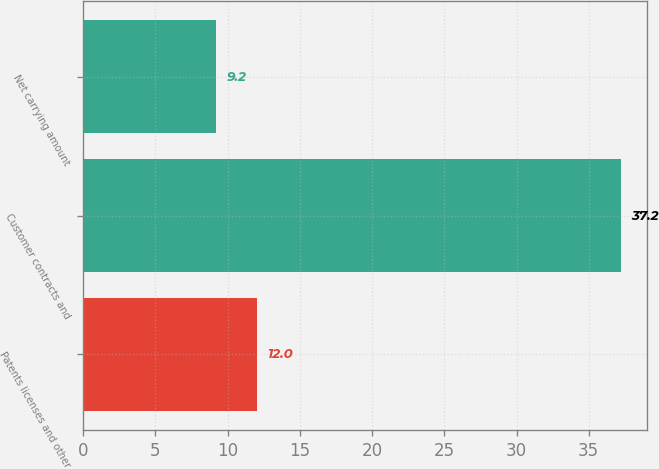Convert chart. <chart><loc_0><loc_0><loc_500><loc_500><bar_chart><fcel>Patents licenses and other<fcel>Customer contracts and<fcel>Net carrying amount<nl><fcel>12<fcel>37.2<fcel>9.2<nl></chart> 